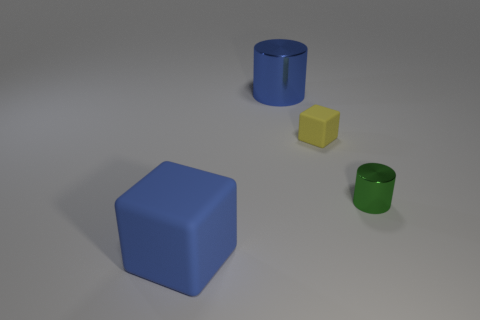Add 1 large cyan shiny cylinders. How many objects exist? 5 Subtract 0 gray cylinders. How many objects are left? 4 Subtract all yellow rubber blocks. Subtract all large blue matte objects. How many objects are left? 2 Add 3 large blocks. How many large blocks are left? 4 Add 1 green metal objects. How many green metal objects exist? 2 